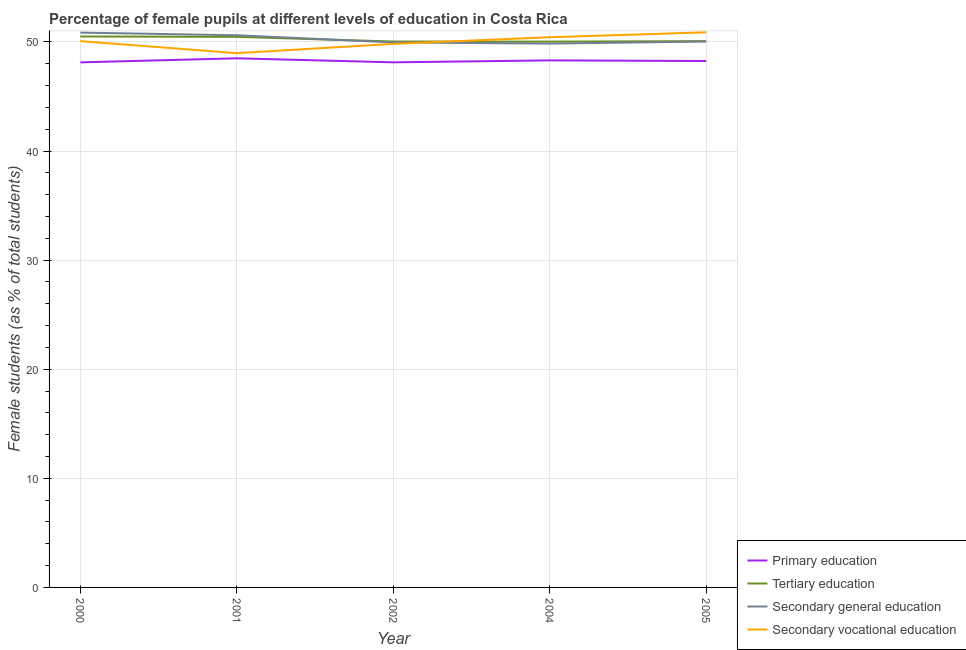How many different coloured lines are there?
Offer a terse response. 4. Does the line corresponding to percentage of female students in primary education intersect with the line corresponding to percentage of female students in secondary vocational education?
Provide a short and direct response. No. What is the percentage of female students in secondary vocational education in 2000?
Give a very brief answer. 50.07. Across all years, what is the maximum percentage of female students in tertiary education?
Give a very brief answer. 50.5. Across all years, what is the minimum percentage of female students in secondary vocational education?
Provide a short and direct response. 48.97. In which year was the percentage of female students in secondary vocational education minimum?
Provide a short and direct response. 2001. What is the total percentage of female students in secondary education in the graph?
Ensure brevity in your answer.  251.3. What is the difference between the percentage of female students in primary education in 2002 and that in 2005?
Ensure brevity in your answer.  -0.12. What is the difference between the percentage of female students in primary education in 2002 and the percentage of female students in secondary vocational education in 2000?
Provide a short and direct response. -1.94. What is the average percentage of female students in primary education per year?
Keep it short and to the point. 48.26. In the year 2000, what is the difference between the percentage of female students in primary education and percentage of female students in secondary education?
Your answer should be compact. -2.73. In how many years, is the percentage of female students in primary education greater than 8 %?
Your answer should be very brief. 5. What is the ratio of the percentage of female students in secondary vocational education in 2000 to that in 2002?
Your answer should be compact. 1.01. Is the percentage of female students in primary education in 2002 less than that in 2005?
Provide a succinct answer. Yes. What is the difference between the highest and the second highest percentage of female students in secondary education?
Give a very brief answer. 0.24. What is the difference between the highest and the lowest percentage of female students in secondary vocational education?
Make the answer very short. 1.91. Is the sum of the percentage of female students in primary education in 2000 and 2001 greater than the maximum percentage of female students in secondary education across all years?
Give a very brief answer. Yes. Does the percentage of female students in primary education monotonically increase over the years?
Make the answer very short. No. How many lines are there?
Your answer should be very brief. 4. How many years are there in the graph?
Ensure brevity in your answer.  5. What is the difference between two consecutive major ticks on the Y-axis?
Provide a succinct answer. 10. Are the values on the major ticks of Y-axis written in scientific E-notation?
Give a very brief answer. No. Does the graph contain grids?
Offer a very short reply. Yes. How many legend labels are there?
Your answer should be compact. 4. How are the legend labels stacked?
Offer a terse response. Vertical. What is the title of the graph?
Provide a short and direct response. Percentage of female pupils at different levels of education in Costa Rica. What is the label or title of the X-axis?
Keep it short and to the point. Year. What is the label or title of the Y-axis?
Make the answer very short. Female students (as % of total students). What is the Female students (as % of total students) in Primary education in 2000?
Offer a very short reply. 48.13. What is the Female students (as % of total students) of Tertiary education in 2000?
Your response must be concise. 50.5. What is the Female students (as % of total students) of Secondary general education in 2000?
Give a very brief answer. 50.85. What is the Female students (as % of total students) of Secondary vocational education in 2000?
Ensure brevity in your answer.  50.07. What is the Female students (as % of total students) of Primary education in 2001?
Keep it short and to the point. 48.5. What is the Female students (as % of total students) of Tertiary education in 2001?
Provide a succinct answer. 50.46. What is the Female students (as % of total students) in Secondary general education in 2001?
Offer a very short reply. 50.61. What is the Female students (as % of total students) of Secondary vocational education in 2001?
Your answer should be very brief. 48.97. What is the Female students (as % of total students) in Primary education in 2002?
Your response must be concise. 48.13. What is the Female students (as % of total students) of Tertiary education in 2002?
Give a very brief answer. 50.04. What is the Female students (as % of total students) of Secondary general education in 2002?
Give a very brief answer. 49.95. What is the Female students (as % of total students) of Secondary vocational education in 2002?
Make the answer very short. 49.82. What is the Female students (as % of total students) in Primary education in 2004?
Your answer should be very brief. 48.31. What is the Female students (as % of total students) in Tertiary education in 2004?
Provide a short and direct response. 50.03. What is the Female students (as % of total students) of Secondary general education in 2004?
Provide a succinct answer. 49.85. What is the Female students (as % of total students) of Secondary vocational education in 2004?
Your answer should be very brief. 50.43. What is the Female students (as % of total students) in Primary education in 2005?
Your answer should be very brief. 48.25. What is the Female students (as % of total students) of Tertiary education in 2005?
Offer a terse response. 50.07. What is the Female students (as % of total students) in Secondary general education in 2005?
Ensure brevity in your answer.  50.04. What is the Female students (as % of total students) of Secondary vocational education in 2005?
Give a very brief answer. 50.88. Across all years, what is the maximum Female students (as % of total students) of Primary education?
Offer a terse response. 48.5. Across all years, what is the maximum Female students (as % of total students) in Tertiary education?
Keep it short and to the point. 50.5. Across all years, what is the maximum Female students (as % of total students) in Secondary general education?
Offer a terse response. 50.85. Across all years, what is the maximum Female students (as % of total students) in Secondary vocational education?
Offer a terse response. 50.88. Across all years, what is the minimum Female students (as % of total students) of Primary education?
Keep it short and to the point. 48.13. Across all years, what is the minimum Female students (as % of total students) of Tertiary education?
Your answer should be compact. 50.03. Across all years, what is the minimum Female students (as % of total students) in Secondary general education?
Your response must be concise. 49.85. Across all years, what is the minimum Female students (as % of total students) in Secondary vocational education?
Provide a succinct answer. 48.97. What is the total Female students (as % of total students) in Primary education in the graph?
Your answer should be compact. 241.31. What is the total Female students (as % of total students) of Tertiary education in the graph?
Your response must be concise. 251.1. What is the total Female students (as % of total students) of Secondary general education in the graph?
Make the answer very short. 251.3. What is the total Female students (as % of total students) in Secondary vocational education in the graph?
Ensure brevity in your answer.  250.17. What is the difference between the Female students (as % of total students) of Primary education in 2000 and that in 2001?
Offer a very short reply. -0.37. What is the difference between the Female students (as % of total students) in Tertiary education in 2000 and that in 2001?
Give a very brief answer. 0.04. What is the difference between the Female students (as % of total students) of Secondary general education in 2000 and that in 2001?
Ensure brevity in your answer.  0.24. What is the difference between the Female students (as % of total students) of Secondary vocational education in 2000 and that in 2001?
Provide a succinct answer. 1.1. What is the difference between the Female students (as % of total students) in Primary education in 2000 and that in 2002?
Your answer should be very brief. -0. What is the difference between the Female students (as % of total students) of Tertiary education in 2000 and that in 2002?
Provide a short and direct response. 0.46. What is the difference between the Female students (as % of total students) of Secondary general education in 2000 and that in 2002?
Offer a very short reply. 0.9. What is the difference between the Female students (as % of total students) in Secondary vocational education in 2000 and that in 2002?
Provide a short and direct response. 0.25. What is the difference between the Female students (as % of total students) in Primary education in 2000 and that in 2004?
Make the answer very short. -0.18. What is the difference between the Female students (as % of total students) of Tertiary education in 2000 and that in 2004?
Your response must be concise. 0.47. What is the difference between the Female students (as % of total students) in Secondary general education in 2000 and that in 2004?
Provide a succinct answer. 1.01. What is the difference between the Female students (as % of total students) of Secondary vocational education in 2000 and that in 2004?
Provide a short and direct response. -0.36. What is the difference between the Female students (as % of total students) in Primary education in 2000 and that in 2005?
Provide a short and direct response. -0.12. What is the difference between the Female students (as % of total students) of Tertiary education in 2000 and that in 2005?
Make the answer very short. 0.43. What is the difference between the Female students (as % of total students) of Secondary general education in 2000 and that in 2005?
Give a very brief answer. 0.81. What is the difference between the Female students (as % of total students) of Secondary vocational education in 2000 and that in 2005?
Your answer should be compact. -0.81. What is the difference between the Female students (as % of total students) in Primary education in 2001 and that in 2002?
Your response must be concise. 0.37. What is the difference between the Female students (as % of total students) of Tertiary education in 2001 and that in 2002?
Give a very brief answer. 0.43. What is the difference between the Female students (as % of total students) of Secondary general education in 2001 and that in 2002?
Provide a succinct answer. 0.66. What is the difference between the Female students (as % of total students) of Secondary vocational education in 2001 and that in 2002?
Make the answer very short. -0.85. What is the difference between the Female students (as % of total students) of Primary education in 2001 and that in 2004?
Provide a short and direct response. 0.19. What is the difference between the Female students (as % of total students) of Tertiary education in 2001 and that in 2004?
Your answer should be compact. 0.44. What is the difference between the Female students (as % of total students) in Secondary general education in 2001 and that in 2004?
Your answer should be very brief. 0.77. What is the difference between the Female students (as % of total students) of Secondary vocational education in 2001 and that in 2004?
Provide a short and direct response. -1.46. What is the difference between the Female students (as % of total students) in Primary education in 2001 and that in 2005?
Make the answer very short. 0.25. What is the difference between the Female students (as % of total students) in Tertiary education in 2001 and that in 2005?
Your answer should be compact. 0.39. What is the difference between the Female students (as % of total students) of Secondary general education in 2001 and that in 2005?
Your answer should be very brief. 0.57. What is the difference between the Female students (as % of total students) of Secondary vocational education in 2001 and that in 2005?
Your answer should be compact. -1.91. What is the difference between the Female students (as % of total students) of Primary education in 2002 and that in 2004?
Give a very brief answer. -0.18. What is the difference between the Female students (as % of total students) of Tertiary education in 2002 and that in 2004?
Provide a succinct answer. 0.01. What is the difference between the Female students (as % of total students) of Secondary general education in 2002 and that in 2004?
Give a very brief answer. 0.11. What is the difference between the Female students (as % of total students) in Secondary vocational education in 2002 and that in 2004?
Offer a terse response. -0.61. What is the difference between the Female students (as % of total students) in Primary education in 2002 and that in 2005?
Your answer should be compact. -0.12. What is the difference between the Female students (as % of total students) of Tertiary education in 2002 and that in 2005?
Give a very brief answer. -0.04. What is the difference between the Female students (as % of total students) in Secondary general education in 2002 and that in 2005?
Keep it short and to the point. -0.08. What is the difference between the Female students (as % of total students) in Secondary vocational education in 2002 and that in 2005?
Keep it short and to the point. -1.06. What is the difference between the Female students (as % of total students) of Primary education in 2004 and that in 2005?
Offer a very short reply. 0.06. What is the difference between the Female students (as % of total students) in Tertiary education in 2004 and that in 2005?
Your answer should be compact. -0.05. What is the difference between the Female students (as % of total students) of Secondary general education in 2004 and that in 2005?
Provide a succinct answer. -0.19. What is the difference between the Female students (as % of total students) in Secondary vocational education in 2004 and that in 2005?
Keep it short and to the point. -0.45. What is the difference between the Female students (as % of total students) in Primary education in 2000 and the Female students (as % of total students) in Tertiary education in 2001?
Provide a short and direct response. -2.34. What is the difference between the Female students (as % of total students) of Primary education in 2000 and the Female students (as % of total students) of Secondary general education in 2001?
Your answer should be very brief. -2.48. What is the difference between the Female students (as % of total students) in Primary education in 2000 and the Female students (as % of total students) in Secondary vocational education in 2001?
Offer a terse response. -0.84. What is the difference between the Female students (as % of total students) of Tertiary education in 2000 and the Female students (as % of total students) of Secondary general education in 2001?
Ensure brevity in your answer.  -0.11. What is the difference between the Female students (as % of total students) in Tertiary education in 2000 and the Female students (as % of total students) in Secondary vocational education in 2001?
Offer a terse response. 1.53. What is the difference between the Female students (as % of total students) in Secondary general education in 2000 and the Female students (as % of total students) in Secondary vocational education in 2001?
Make the answer very short. 1.88. What is the difference between the Female students (as % of total students) in Primary education in 2000 and the Female students (as % of total students) in Tertiary education in 2002?
Give a very brief answer. -1.91. What is the difference between the Female students (as % of total students) in Primary education in 2000 and the Female students (as % of total students) in Secondary general education in 2002?
Provide a succinct answer. -1.83. What is the difference between the Female students (as % of total students) of Primary education in 2000 and the Female students (as % of total students) of Secondary vocational education in 2002?
Make the answer very short. -1.69. What is the difference between the Female students (as % of total students) of Tertiary education in 2000 and the Female students (as % of total students) of Secondary general education in 2002?
Provide a short and direct response. 0.55. What is the difference between the Female students (as % of total students) in Tertiary education in 2000 and the Female students (as % of total students) in Secondary vocational education in 2002?
Keep it short and to the point. 0.68. What is the difference between the Female students (as % of total students) of Secondary general education in 2000 and the Female students (as % of total students) of Secondary vocational education in 2002?
Your response must be concise. 1.03. What is the difference between the Female students (as % of total students) of Primary education in 2000 and the Female students (as % of total students) of Tertiary education in 2004?
Offer a terse response. -1.9. What is the difference between the Female students (as % of total students) in Primary education in 2000 and the Female students (as % of total students) in Secondary general education in 2004?
Ensure brevity in your answer.  -1.72. What is the difference between the Female students (as % of total students) in Primary education in 2000 and the Female students (as % of total students) in Secondary vocational education in 2004?
Provide a succinct answer. -2.3. What is the difference between the Female students (as % of total students) of Tertiary education in 2000 and the Female students (as % of total students) of Secondary general education in 2004?
Your answer should be compact. 0.65. What is the difference between the Female students (as % of total students) in Tertiary education in 2000 and the Female students (as % of total students) in Secondary vocational education in 2004?
Offer a terse response. 0.07. What is the difference between the Female students (as % of total students) of Secondary general education in 2000 and the Female students (as % of total students) of Secondary vocational education in 2004?
Offer a very short reply. 0.42. What is the difference between the Female students (as % of total students) of Primary education in 2000 and the Female students (as % of total students) of Tertiary education in 2005?
Provide a succinct answer. -1.94. What is the difference between the Female students (as % of total students) in Primary education in 2000 and the Female students (as % of total students) in Secondary general education in 2005?
Your response must be concise. -1.91. What is the difference between the Female students (as % of total students) in Primary education in 2000 and the Female students (as % of total students) in Secondary vocational education in 2005?
Your answer should be compact. -2.75. What is the difference between the Female students (as % of total students) in Tertiary education in 2000 and the Female students (as % of total students) in Secondary general education in 2005?
Give a very brief answer. 0.46. What is the difference between the Female students (as % of total students) in Tertiary education in 2000 and the Female students (as % of total students) in Secondary vocational education in 2005?
Keep it short and to the point. -0.38. What is the difference between the Female students (as % of total students) of Secondary general education in 2000 and the Female students (as % of total students) of Secondary vocational education in 2005?
Your answer should be very brief. -0.03. What is the difference between the Female students (as % of total students) in Primary education in 2001 and the Female students (as % of total students) in Tertiary education in 2002?
Your answer should be very brief. -1.54. What is the difference between the Female students (as % of total students) in Primary education in 2001 and the Female students (as % of total students) in Secondary general education in 2002?
Your answer should be very brief. -1.46. What is the difference between the Female students (as % of total students) of Primary education in 2001 and the Female students (as % of total students) of Secondary vocational education in 2002?
Provide a succinct answer. -1.32. What is the difference between the Female students (as % of total students) of Tertiary education in 2001 and the Female students (as % of total students) of Secondary general education in 2002?
Provide a short and direct response. 0.51. What is the difference between the Female students (as % of total students) in Tertiary education in 2001 and the Female students (as % of total students) in Secondary vocational education in 2002?
Your answer should be compact. 0.64. What is the difference between the Female students (as % of total students) of Secondary general education in 2001 and the Female students (as % of total students) of Secondary vocational education in 2002?
Provide a succinct answer. 0.79. What is the difference between the Female students (as % of total students) of Primary education in 2001 and the Female students (as % of total students) of Tertiary education in 2004?
Make the answer very short. -1.53. What is the difference between the Female students (as % of total students) of Primary education in 2001 and the Female students (as % of total students) of Secondary general education in 2004?
Offer a very short reply. -1.35. What is the difference between the Female students (as % of total students) of Primary education in 2001 and the Female students (as % of total students) of Secondary vocational education in 2004?
Your answer should be very brief. -1.93. What is the difference between the Female students (as % of total students) in Tertiary education in 2001 and the Female students (as % of total students) in Secondary general education in 2004?
Offer a very short reply. 0.62. What is the difference between the Female students (as % of total students) of Tertiary education in 2001 and the Female students (as % of total students) of Secondary vocational education in 2004?
Your response must be concise. 0.03. What is the difference between the Female students (as % of total students) in Secondary general education in 2001 and the Female students (as % of total students) in Secondary vocational education in 2004?
Provide a succinct answer. 0.18. What is the difference between the Female students (as % of total students) of Primary education in 2001 and the Female students (as % of total students) of Tertiary education in 2005?
Offer a terse response. -1.57. What is the difference between the Female students (as % of total students) of Primary education in 2001 and the Female students (as % of total students) of Secondary general education in 2005?
Offer a terse response. -1.54. What is the difference between the Female students (as % of total students) in Primary education in 2001 and the Female students (as % of total students) in Secondary vocational education in 2005?
Offer a terse response. -2.38. What is the difference between the Female students (as % of total students) in Tertiary education in 2001 and the Female students (as % of total students) in Secondary general education in 2005?
Offer a terse response. 0.43. What is the difference between the Female students (as % of total students) in Tertiary education in 2001 and the Female students (as % of total students) in Secondary vocational education in 2005?
Your answer should be very brief. -0.42. What is the difference between the Female students (as % of total students) of Secondary general education in 2001 and the Female students (as % of total students) of Secondary vocational education in 2005?
Give a very brief answer. -0.27. What is the difference between the Female students (as % of total students) in Primary education in 2002 and the Female students (as % of total students) in Tertiary education in 2004?
Provide a succinct answer. -1.9. What is the difference between the Female students (as % of total students) of Primary education in 2002 and the Female students (as % of total students) of Secondary general education in 2004?
Give a very brief answer. -1.72. What is the difference between the Female students (as % of total students) of Primary education in 2002 and the Female students (as % of total students) of Secondary vocational education in 2004?
Keep it short and to the point. -2.3. What is the difference between the Female students (as % of total students) of Tertiary education in 2002 and the Female students (as % of total students) of Secondary general education in 2004?
Your response must be concise. 0.19. What is the difference between the Female students (as % of total students) in Tertiary education in 2002 and the Female students (as % of total students) in Secondary vocational education in 2004?
Offer a very short reply. -0.39. What is the difference between the Female students (as % of total students) in Secondary general education in 2002 and the Female students (as % of total students) in Secondary vocational education in 2004?
Your answer should be compact. -0.48. What is the difference between the Female students (as % of total students) in Primary education in 2002 and the Female students (as % of total students) in Tertiary education in 2005?
Your response must be concise. -1.94. What is the difference between the Female students (as % of total students) in Primary education in 2002 and the Female students (as % of total students) in Secondary general education in 2005?
Your answer should be compact. -1.91. What is the difference between the Female students (as % of total students) in Primary education in 2002 and the Female students (as % of total students) in Secondary vocational education in 2005?
Make the answer very short. -2.75. What is the difference between the Female students (as % of total students) of Tertiary education in 2002 and the Female students (as % of total students) of Secondary general education in 2005?
Provide a succinct answer. -0. What is the difference between the Female students (as % of total students) in Tertiary education in 2002 and the Female students (as % of total students) in Secondary vocational education in 2005?
Provide a succinct answer. -0.84. What is the difference between the Female students (as % of total students) in Secondary general education in 2002 and the Female students (as % of total students) in Secondary vocational education in 2005?
Give a very brief answer. -0.93. What is the difference between the Female students (as % of total students) of Primary education in 2004 and the Female students (as % of total students) of Tertiary education in 2005?
Offer a very short reply. -1.76. What is the difference between the Female students (as % of total students) of Primary education in 2004 and the Female students (as % of total students) of Secondary general education in 2005?
Your response must be concise. -1.73. What is the difference between the Female students (as % of total students) in Primary education in 2004 and the Female students (as % of total students) in Secondary vocational education in 2005?
Your answer should be very brief. -2.57. What is the difference between the Female students (as % of total students) in Tertiary education in 2004 and the Female students (as % of total students) in Secondary general education in 2005?
Offer a very short reply. -0.01. What is the difference between the Female students (as % of total students) in Tertiary education in 2004 and the Female students (as % of total students) in Secondary vocational education in 2005?
Your answer should be compact. -0.85. What is the difference between the Female students (as % of total students) of Secondary general education in 2004 and the Female students (as % of total students) of Secondary vocational education in 2005?
Offer a very short reply. -1.03. What is the average Female students (as % of total students) of Primary education per year?
Keep it short and to the point. 48.26. What is the average Female students (as % of total students) of Tertiary education per year?
Your response must be concise. 50.22. What is the average Female students (as % of total students) of Secondary general education per year?
Give a very brief answer. 50.26. What is the average Female students (as % of total students) of Secondary vocational education per year?
Your answer should be compact. 50.03. In the year 2000, what is the difference between the Female students (as % of total students) of Primary education and Female students (as % of total students) of Tertiary education?
Make the answer very short. -2.37. In the year 2000, what is the difference between the Female students (as % of total students) of Primary education and Female students (as % of total students) of Secondary general education?
Keep it short and to the point. -2.73. In the year 2000, what is the difference between the Female students (as % of total students) in Primary education and Female students (as % of total students) in Secondary vocational education?
Keep it short and to the point. -1.95. In the year 2000, what is the difference between the Female students (as % of total students) of Tertiary education and Female students (as % of total students) of Secondary general education?
Keep it short and to the point. -0.35. In the year 2000, what is the difference between the Female students (as % of total students) in Tertiary education and Female students (as % of total students) in Secondary vocational education?
Your answer should be very brief. 0.43. In the year 2000, what is the difference between the Female students (as % of total students) of Secondary general education and Female students (as % of total students) of Secondary vocational education?
Make the answer very short. 0.78. In the year 2001, what is the difference between the Female students (as % of total students) in Primary education and Female students (as % of total students) in Tertiary education?
Provide a succinct answer. -1.97. In the year 2001, what is the difference between the Female students (as % of total students) in Primary education and Female students (as % of total students) in Secondary general education?
Provide a short and direct response. -2.11. In the year 2001, what is the difference between the Female students (as % of total students) of Primary education and Female students (as % of total students) of Secondary vocational education?
Your answer should be compact. -0.47. In the year 2001, what is the difference between the Female students (as % of total students) in Tertiary education and Female students (as % of total students) in Secondary general education?
Keep it short and to the point. -0.15. In the year 2001, what is the difference between the Female students (as % of total students) of Tertiary education and Female students (as % of total students) of Secondary vocational education?
Make the answer very short. 1.49. In the year 2001, what is the difference between the Female students (as % of total students) in Secondary general education and Female students (as % of total students) in Secondary vocational education?
Provide a succinct answer. 1.64. In the year 2002, what is the difference between the Female students (as % of total students) in Primary education and Female students (as % of total students) in Tertiary education?
Offer a terse response. -1.91. In the year 2002, what is the difference between the Female students (as % of total students) in Primary education and Female students (as % of total students) in Secondary general education?
Provide a short and direct response. -1.82. In the year 2002, what is the difference between the Female students (as % of total students) of Primary education and Female students (as % of total students) of Secondary vocational education?
Offer a terse response. -1.69. In the year 2002, what is the difference between the Female students (as % of total students) of Tertiary education and Female students (as % of total students) of Secondary general education?
Ensure brevity in your answer.  0.08. In the year 2002, what is the difference between the Female students (as % of total students) of Tertiary education and Female students (as % of total students) of Secondary vocational education?
Ensure brevity in your answer.  0.22. In the year 2002, what is the difference between the Female students (as % of total students) in Secondary general education and Female students (as % of total students) in Secondary vocational education?
Make the answer very short. 0.13. In the year 2004, what is the difference between the Female students (as % of total students) in Primary education and Female students (as % of total students) in Tertiary education?
Your response must be concise. -1.72. In the year 2004, what is the difference between the Female students (as % of total students) in Primary education and Female students (as % of total students) in Secondary general education?
Provide a short and direct response. -1.54. In the year 2004, what is the difference between the Female students (as % of total students) of Primary education and Female students (as % of total students) of Secondary vocational education?
Your answer should be very brief. -2.12. In the year 2004, what is the difference between the Female students (as % of total students) in Tertiary education and Female students (as % of total students) in Secondary general education?
Give a very brief answer. 0.18. In the year 2004, what is the difference between the Female students (as % of total students) in Tertiary education and Female students (as % of total students) in Secondary vocational education?
Keep it short and to the point. -0.4. In the year 2004, what is the difference between the Female students (as % of total students) in Secondary general education and Female students (as % of total students) in Secondary vocational education?
Offer a terse response. -0.58. In the year 2005, what is the difference between the Female students (as % of total students) in Primary education and Female students (as % of total students) in Tertiary education?
Keep it short and to the point. -1.82. In the year 2005, what is the difference between the Female students (as % of total students) in Primary education and Female students (as % of total students) in Secondary general education?
Keep it short and to the point. -1.79. In the year 2005, what is the difference between the Female students (as % of total students) of Primary education and Female students (as % of total students) of Secondary vocational education?
Provide a short and direct response. -2.63. In the year 2005, what is the difference between the Female students (as % of total students) in Tertiary education and Female students (as % of total students) in Secondary general education?
Provide a succinct answer. 0.03. In the year 2005, what is the difference between the Female students (as % of total students) in Tertiary education and Female students (as % of total students) in Secondary vocational education?
Your answer should be compact. -0.81. In the year 2005, what is the difference between the Female students (as % of total students) in Secondary general education and Female students (as % of total students) in Secondary vocational education?
Your response must be concise. -0.84. What is the ratio of the Female students (as % of total students) in Primary education in 2000 to that in 2001?
Keep it short and to the point. 0.99. What is the ratio of the Female students (as % of total students) in Secondary general education in 2000 to that in 2001?
Offer a very short reply. 1. What is the ratio of the Female students (as % of total students) in Secondary vocational education in 2000 to that in 2001?
Your response must be concise. 1.02. What is the ratio of the Female students (as % of total students) in Tertiary education in 2000 to that in 2002?
Give a very brief answer. 1.01. What is the ratio of the Female students (as % of total students) in Tertiary education in 2000 to that in 2004?
Keep it short and to the point. 1.01. What is the ratio of the Female students (as % of total students) of Secondary general education in 2000 to that in 2004?
Offer a terse response. 1.02. What is the ratio of the Female students (as % of total students) in Primary education in 2000 to that in 2005?
Your response must be concise. 1. What is the ratio of the Female students (as % of total students) in Tertiary education in 2000 to that in 2005?
Your response must be concise. 1.01. What is the ratio of the Female students (as % of total students) in Secondary general education in 2000 to that in 2005?
Provide a short and direct response. 1.02. What is the ratio of the Female students (as % of total students) in Secondary vocational education in 2000 to that in 2005?
Ensure brevity in your answer.  0.98. What is the ratio of the Female students (as % of total students) in Primary education in 2001 to that in 2002?
Keep it short and to the point. 1.01. What is the ratio of the Female students (as % of total students) in Tertiary education in 2001 to that in 2002?
Offer a terse response. 1.01. What is the ratio of the Female students (as % of total students) in Secondary general education in 2001 to that in 2002?
Give a very brief answer. 1.01. What is the ratio of the Female students (as % of total students) in Secondary vocational education in 2001 to that in 2002?
Give a very brief answer. 0.98. What is the ratio of the Female students (as % of total students) in Tertiary education in 2001 to that in 2004?
Provide a short and direct response. 1.01. What is the ratio of the Female students (as % of total students) in Secondary general education in 2001 to that in 2004?
Provide a succinct answer. 1.02. What is the ratio of the Female students (as % of total students) in Secondary general education in 2001 to that in 2005?
Ensure brevity in your answer.  1.01. What is the ratio of the Female students (as % of total students) of Secondary vocational education in 2001 to that in 2005?
Provide a short and direct response. 0.96. What is the ratio of the Female students (as % of total students) in Secondary vocational education in 2002 to that in 2004?
Offer a terse response. 0.99. What is the ratio of the Female students (as % of total students) in Primary education in 2002 to that in 2005?
Your response must be concise. 1. What is the ratio of the Female students (as % of total students) in Tertiary education in 2002 to that in 2005?
Make the answer very short. 1. What is the ratio of the Female students (as % of total students) in Secondary general education in 2002 to that in 2005?
Provide a succinct answer. 1. What is the ratio of the Female students (as % of total students) in Secondary vocational education in 2002 to that in 2005?
Your response must be concise. 0.98. What is the ratio of the Female students (as % of total students) of Primary education in 2004 to that in 2005?
Make the answer very short. 1. What is the ratio of the Female students (as % of total students) in Tertiary education in 2004 to that in 2005?
Provide a short and direct response. 1. What is the ratio of the Female students (as % of total students) in Secondary vocational education in 2004 to that in 2005?
Give a very brief answer. 0.99. What is the difference between the highest and the second highest Female students (as % of total students) in Primary education?
Provide a succinct answer. 0.19. What is the difference between the highest and the second highest Female students (as % of total students) of Tertiary education?
Provide a succinct answer. 0.04. What is the difference between the highest and the second highest Female students (as % of total students) in Secondary general education?
Give a very brief answer. 0.24. What is the difference between the highest and the second highest Female students (as % of total students) of Secondary vocational education?
Ensure brevity in your answer.  0.45. What is the difference between the highest and the lowest Female students (as % of total students) of Primary education?
Provide a succinct answer. 0.37. What is the difference between the highest and the lowest Female students (as % of total students) in Tertiary education?
Your response must be concise. 0.47. What is the difference between the highest and the lowest Female students (as % of total students) of Secondary general education?
Your response must be concise. 1.01. What is the difference between the highest and the lowest Female students (as % of total students) in Secondary vocational education?
Your response must be concise. 1.91. 